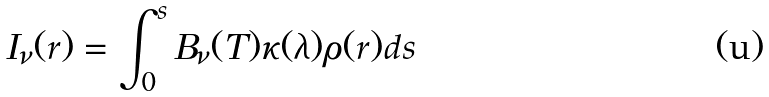<formula> <loc_0><loc_0><loc_500><loc_500>I _ { \nu } ( r ) = \int _ { 0 } ^ { s } B _ { \nu } ( T ) \kappa ( \lambda ) \rho ( r ) d s</formula> 